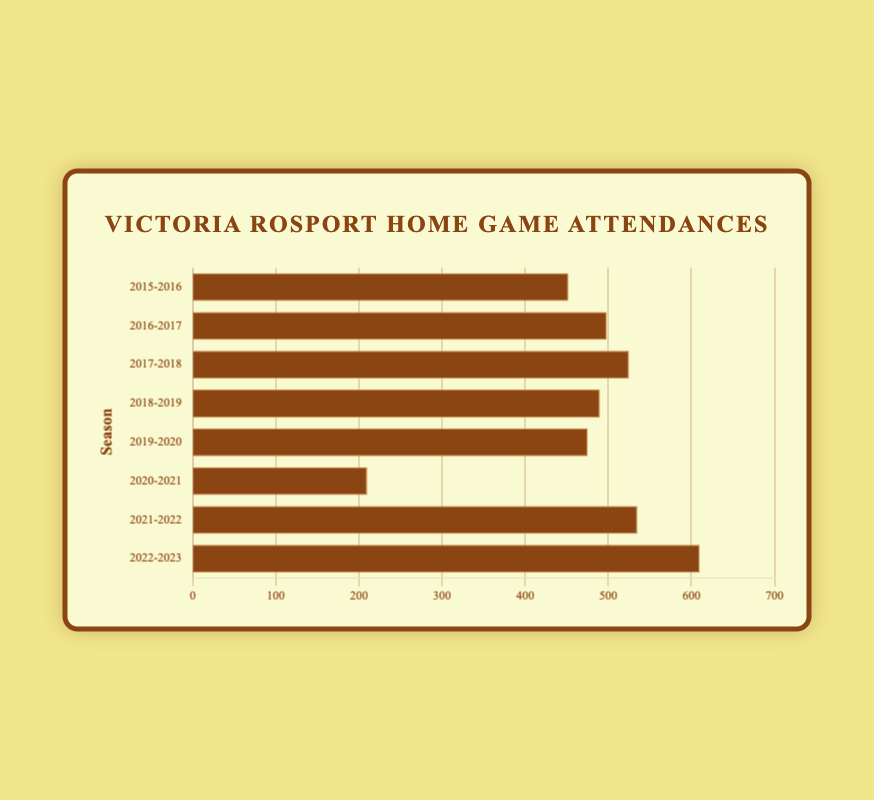What is the average attendance in the 2020-2021 season? Look at the bar corresponding to the 2020-2021 season and read the attendance number.
Answer: 210 Which season had the highest average attendance? Compare the heights of all the bars and identify the tallest one which represents the highest attendance.
Answer: 2022-2023 By which value did the average attendance increase from the 2019-2020 season to the 2021-2022 season? Subtract the attendance of the 2019-2020 season (475) from the attendance of the 2021-2022 season (535).
Answer: 60 What is the total average attendance over all seasons? Sum all the average attendance values for each season: 452 + 498 + 525 + 490 + 475 + 210 + 535 + 610.
Answer: 3795 Which two consecutive seasons had the largest increase in average attendance? Calculate the difference in average attendance for each pair of consecutive seasons and find the pair with the largest positive difference.
Answer: 2021-2022 to 2022-2023 How does the average attendance in the 2017-2018 season compare to the 2020-2021 season? Compare the attendance values of these two seasons: 525 (2017-2018) and 210 (2020-2021).
Answer: 2017-2018 is higher What is the average attendance considering only the 2015-2016 to 2019-2020 seasons? Calculate the average of the first five seasons by summing: 452 + 498 + 525 + 490 + 475 and dividing by 5.
Answer: 488 During which season did the average attendance drop most significantly compared to the previous season? Calculate the difference for each pair of consecutive seasons and identify the largest negative value.
Answer: 2019-2020 to 2020-2021 What is the difference in average attendance between the season with the maximum and minimum values? Find the maximum (610 in 2022-2023) and minimum (210 in 2020-2021) attendance values and subtract the latter from the former.
Answer: 400 How many seasons had an average attendance greater than 500? Count the bars with attendance values above 500: 2017-2018 (525), 2021-2022 (535), and 2022-2023 (610).
Answer: 3 